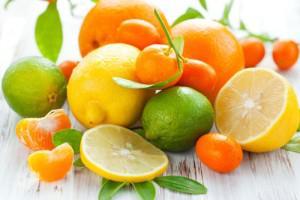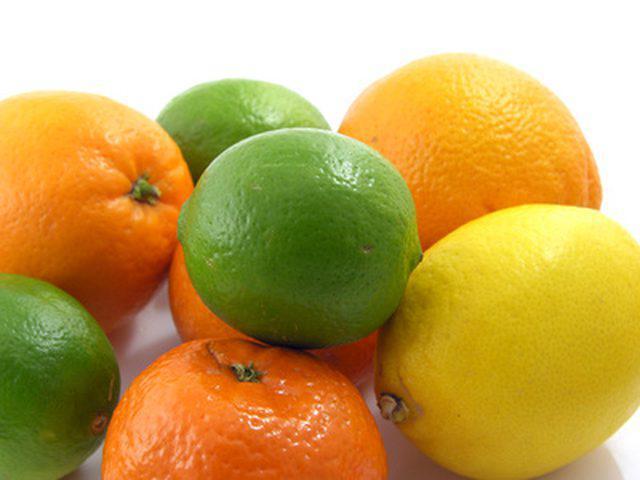The first image is the image on the left, the second image is the image on the right. Examine the images to the left and right. Is the description "The left image includes a variety of whole citrus fruits, along with at least one cut fruit and green leaves." accurate? Answer yes or no. Yes. The first image is the image on the left, the second image is the image on the right. Analyze the images presented: Is the assertion "In at least one image there is a single lemon next to two green leaves." valid? Answer yes or no. No. 